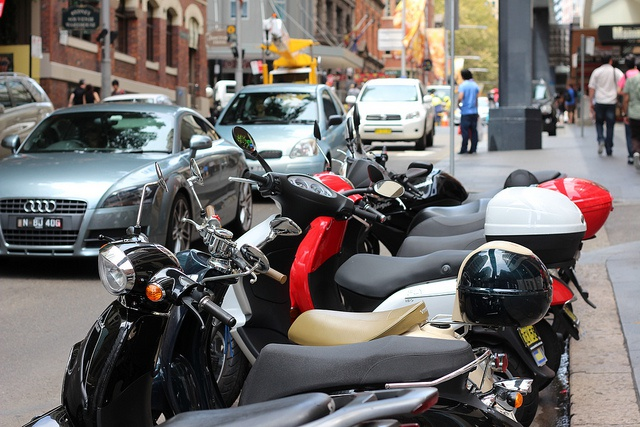Describe the objects in this image and their specific colors. I can see motorcycle in red, black, gray, darkgray, and white tones, car in red, black, gray, white, and darkgray tones, motorcycle in red, black, lightgray, darkgray, and gray tones, motorcycle in red, black, gray, white, and darkgray tones, and car in red, white, black, darkgray, and gray tones in this image. 